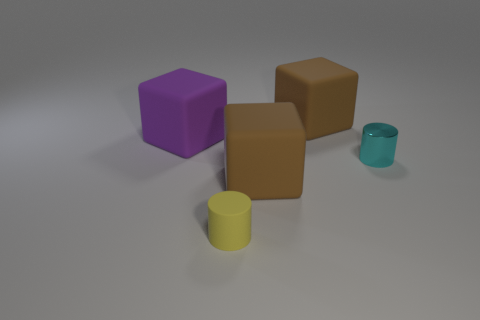What number of things are either gray metallic things or yellow matte things that are left of the small cyan thing?
Make the answer very short. 1. Is the shape of the rubber thing that is behind the big purple rubber object the same as  the purple matte thing?
Make the answer very short. Yes. There is a large block that is on the left side of the big brown block in front of the large purple matte object; how many big purple cubes are behind it?
Your answer should be compact. 0. How many objects are either yellow shiny cubes or tiny rubber cylinders?
Make the answer very short. 1. There is a yellow rubber object; does it have the same shape as the tiny thing to the right of the small yellow matte thing?
Offer a very short reply. Yes. There is a metal object that is right of the purple object; what shape is it?
Provide a short and direct response. Cylinder. Does the tiny cyan object have the same shape as the tiny rubber thing?
Your answer should be compact. Yes. There is a brown matte object in front of the metal cylinder; is it the same size as the cyan shiny cylinder?
Offer a very short reply. No. There is a thing that is both to the right of the yellow cylinder and in front of the small cyan shiny cylinder; what size is it?
Your answer should be compact. Large. Is the number of cyan objects behind the purple rubber cube the same as the number of small spheres?
Provide a short and direct response. Yes. 